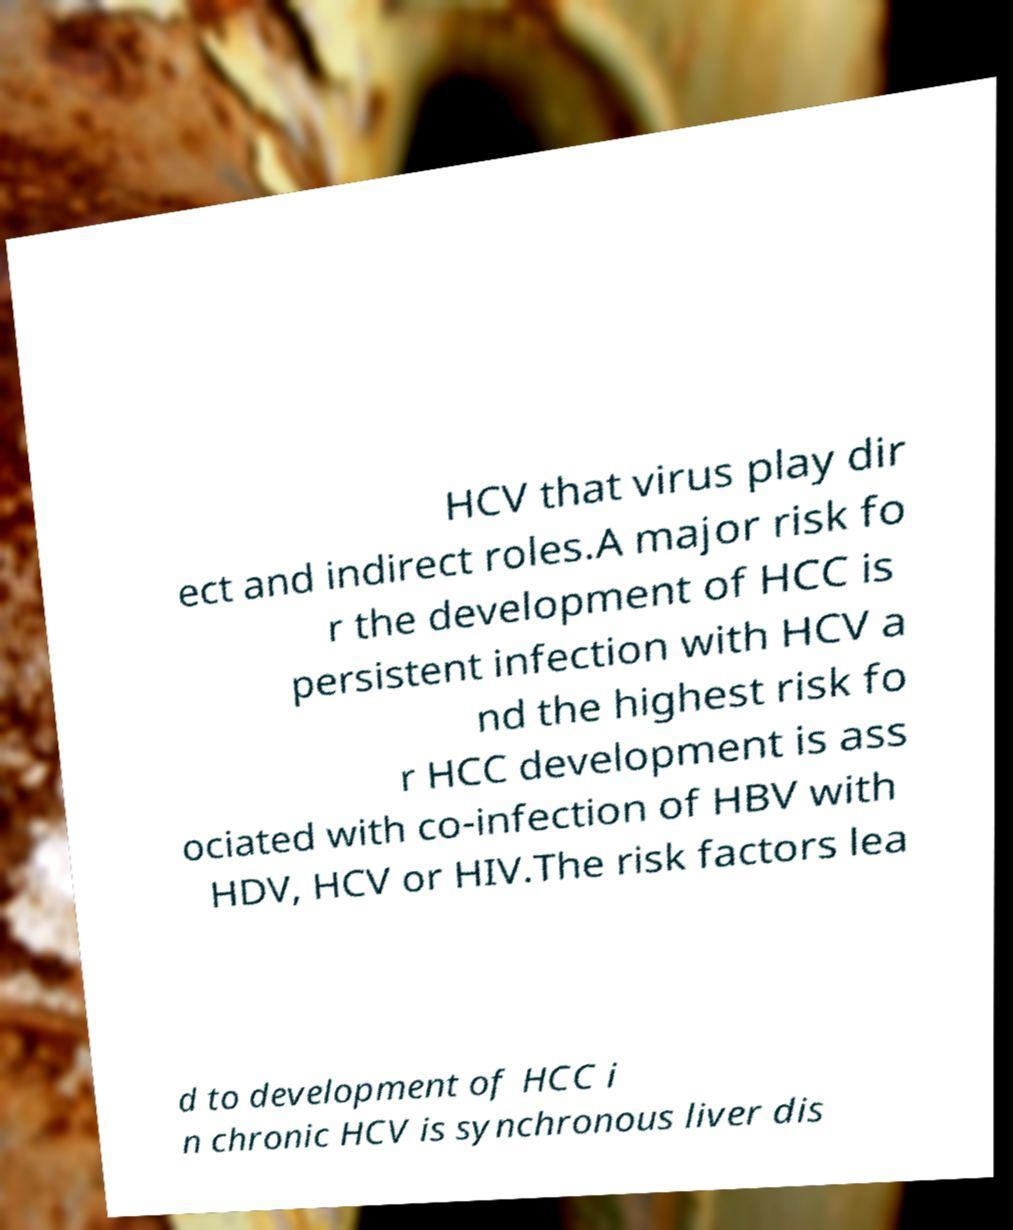Can you read and provide the text displayed in the image?This photo seems to have some interesting text. Can you extract and type it out for me? HCV that virus play dir ect and indirect roles.A major risk fo r the development of HCC is persistent infection with HCV a nd the highest risk fo r HCC development is ass ociated with co-infection of HBV with HDV, HCV or HIV.The risk factors lea d to development of HCC i n chronic HCV is synchronous liver dis 